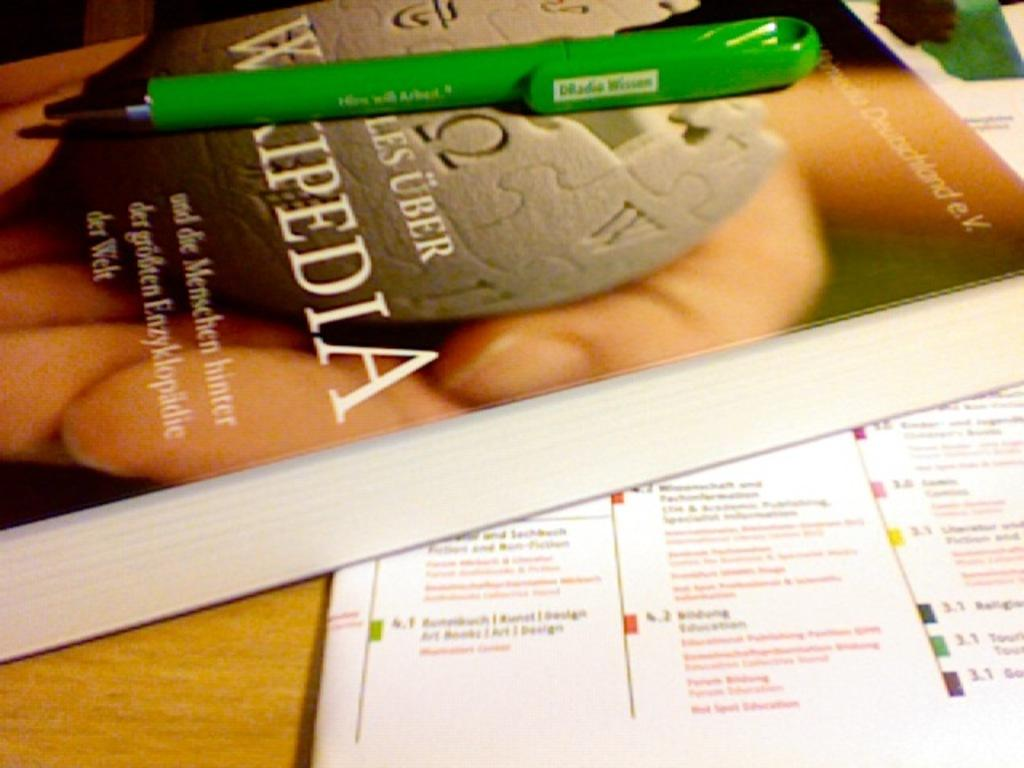<image>
Relay a brief, clear account of the picture shown. a Wikipedia book is next to some paper 